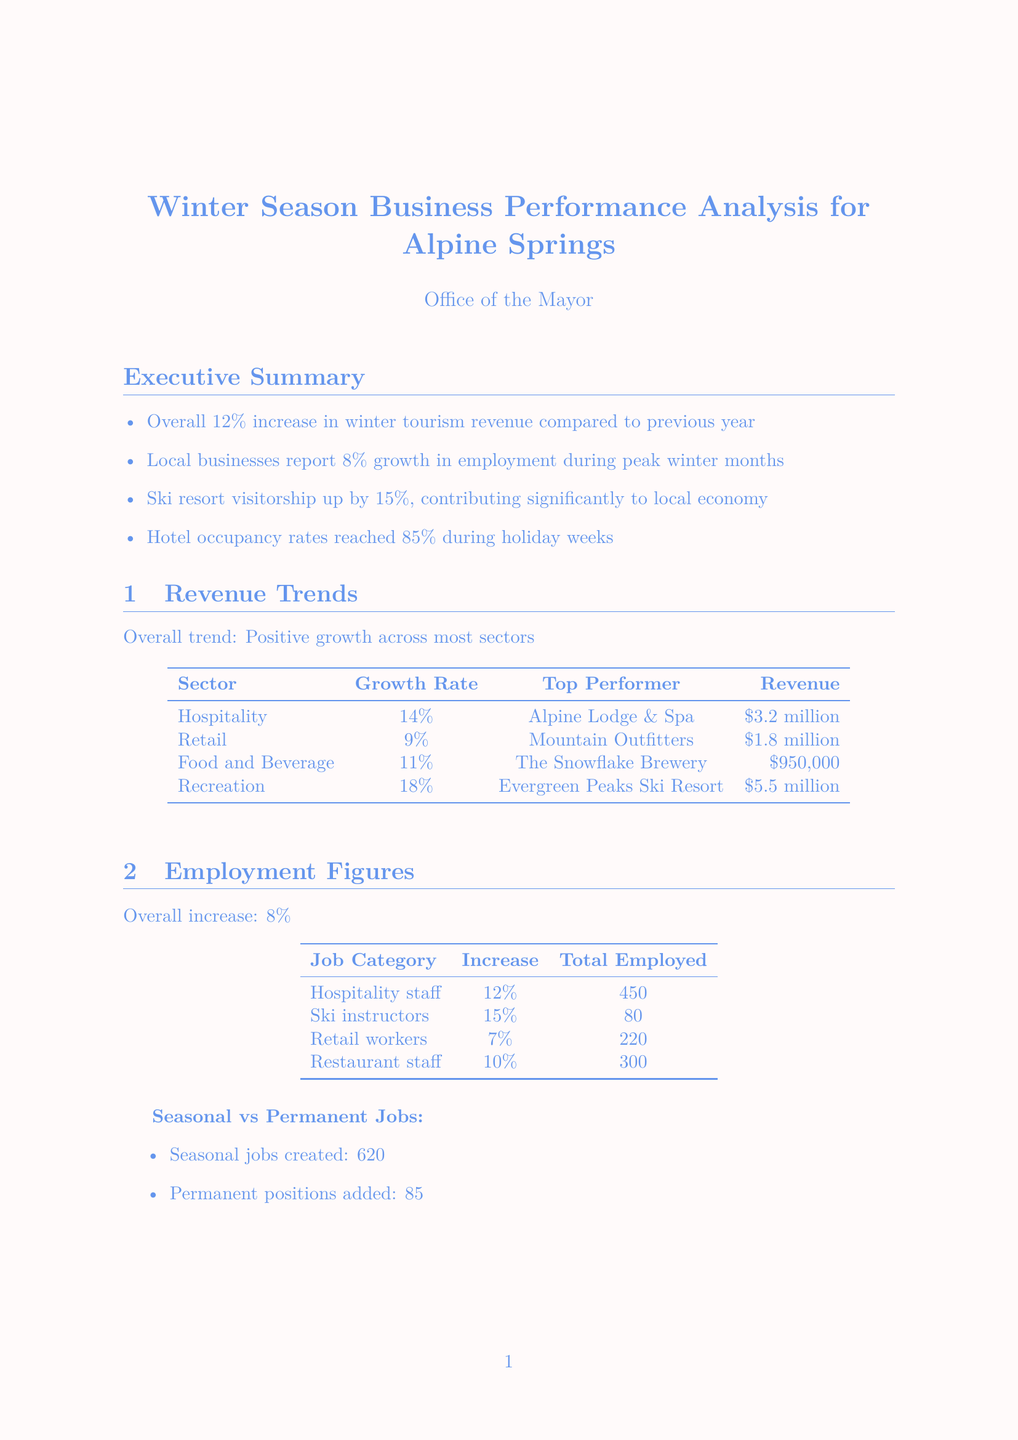What was the overall increase in winter tourism revenue? The document states an overall increase of 12% in winter tourism revenue compared to the previous year.
Answer: 12% Which sector had the highest growth rate? The Recreation sector had the highest growth rate of 18%.
Answer: 18% What is the total number of seasonal jobs created? The document mentions that 620 seasonal jobs were created during the winter season.
Answer: 620 Who was the top performer in the Food and Beverage sector? The top performer in the Food and Beverage sector is The Snowflake Brewery.
Answer: The Snowflake Brewery What percentage of hotel occupancy was reached during holiday weeks? The report indicates that hotel occupancy rates reached 85% during holiday weeks.
Answer: 85% What are two challenges mentioned in the report? The challenges noted include limited affordable housing for seasonal workers and peak season strain on local infrastructure.
Answer: Limited affordable housing for seasonal workers; peak season strain on local infrastructure What is the expected growth for the next season? The document forecasts an expected growth of 10-15% for the next winter season.
Answer: 10-15% Which local business introduced winter-themed flavors? The document highlights Frosty's Artisan Ice Cream as the business that introduced winter-themed flavors.
Answer: Frosty's Artisan Ice Cream What number of permanent positions was added? The report states that 85 permanent positions were added during the winter months.
Answer: 85 